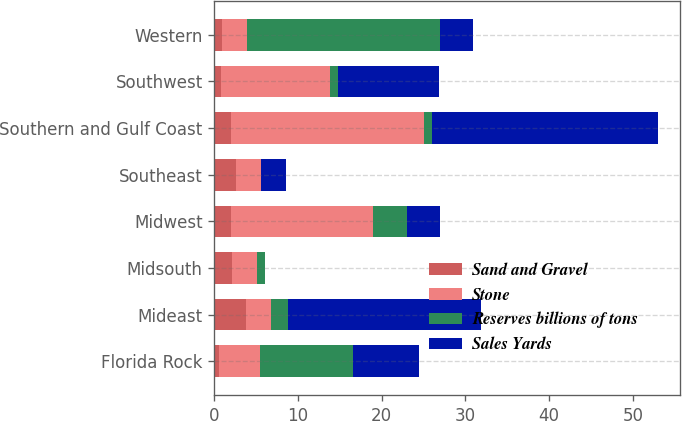Convert chart. <chart><loc_0><loc_0><loc_500><loc_500><stacked_bar_chart><ecel><fcel>Florida Rock<fcel>Mideast<fcel>Midsouth<fcel>Midwest<fcel>Southeast<fcel>Southern and Gulf Coast<fcel>Southwest<fcel>Western<nl><fcel>Sand and Gravel<fcel>0.5<fcel>3.8<fcel>2.1<fcel>2<fcel>2.6<fcel>2<fcel>0.8<fcel>0.9<nl><fcel>Stone<fcel>5<fcel>3<fcel>3<fcel>17<fcel>3<fcel>23<fcel>13<fcel>3<nl><fcel>Reserves billions of tons<fcel>11<fcel>2<fcel>1<fcel>4<fcel>0<fcel>1<fcel>1<fcel>23<nl><fcel>Sales Yards<fcel>8<fcel>23<fcel>0<fcel>4<fcel>3<fcel>27<fcel>12<fcel>4<nl></chart> 